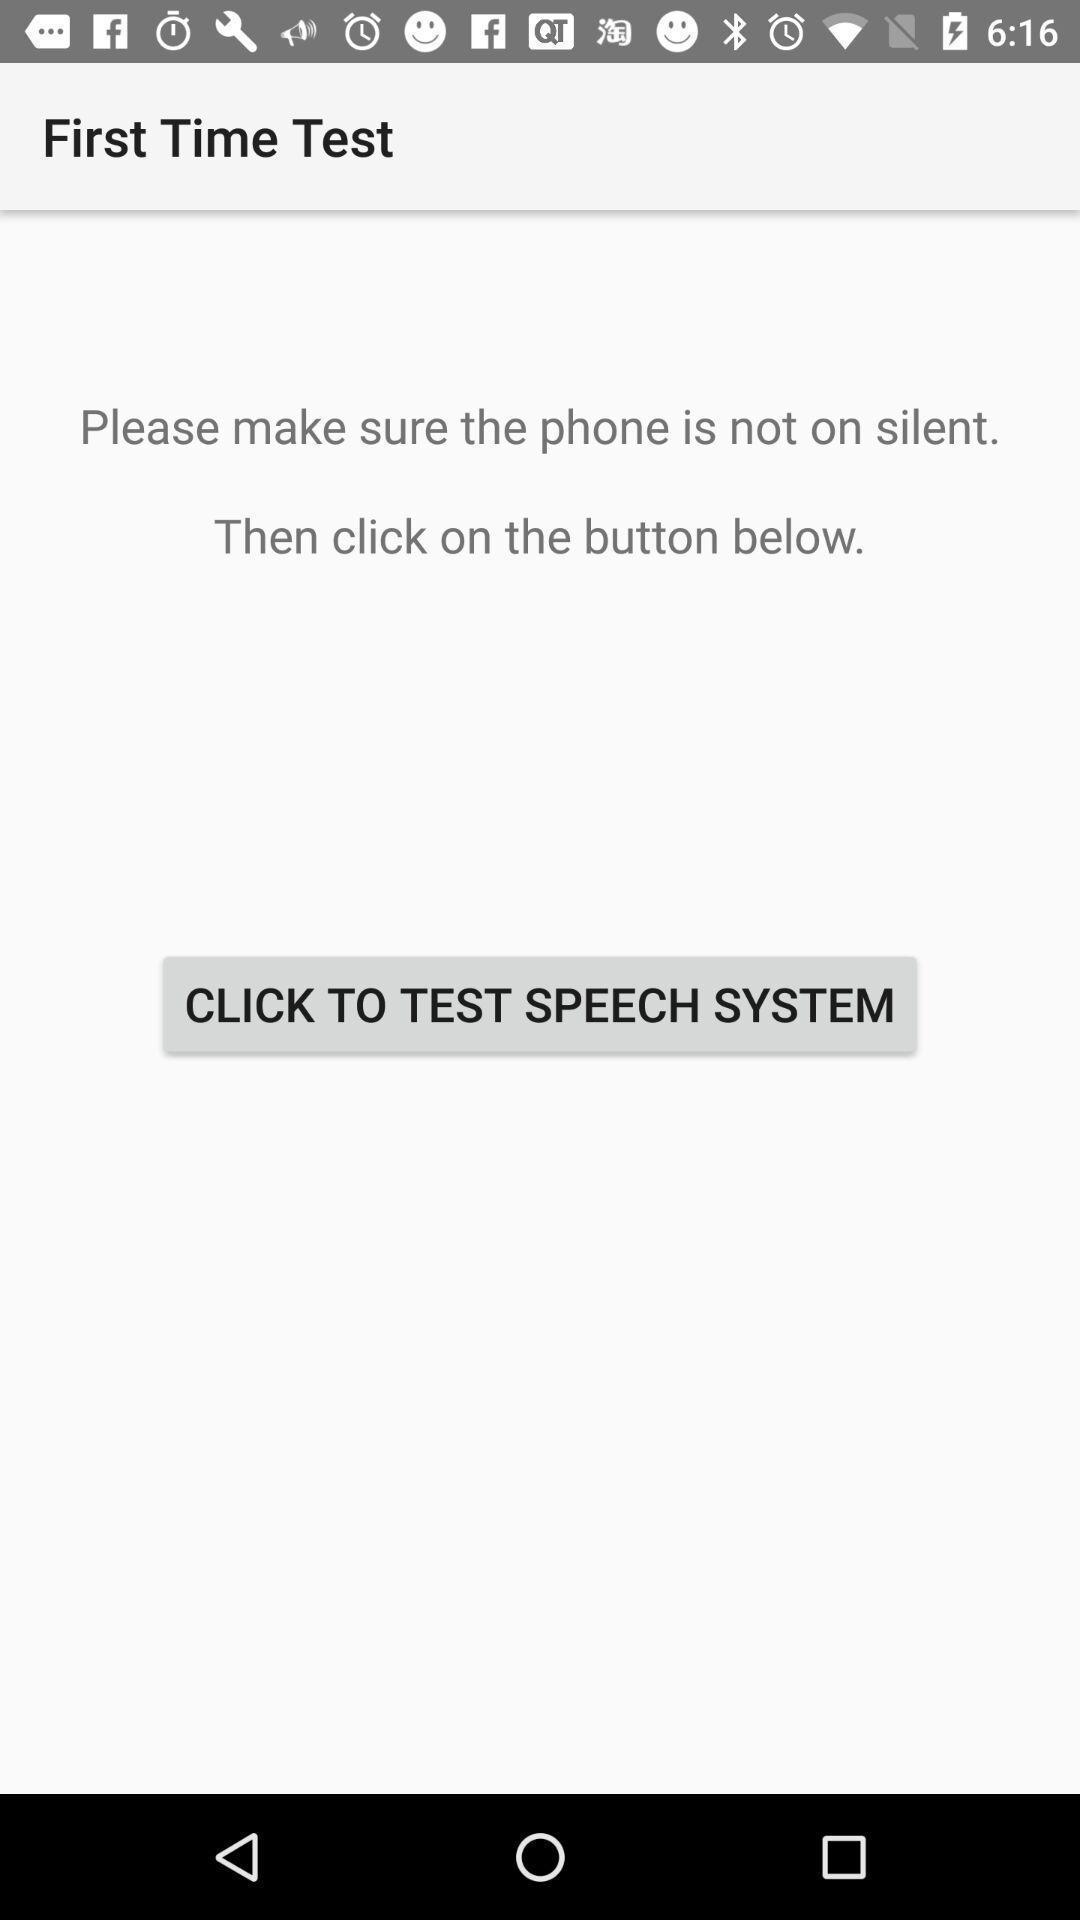Please provide a description for this image. Starting page displaying about a feature. 